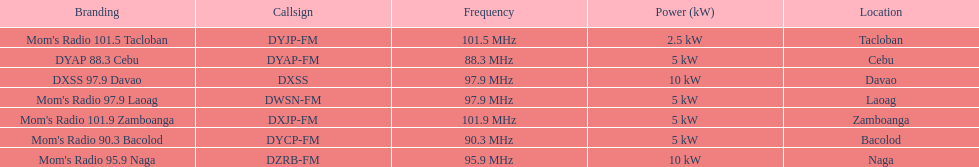What is the overall count of radio stations on this list? 7. 